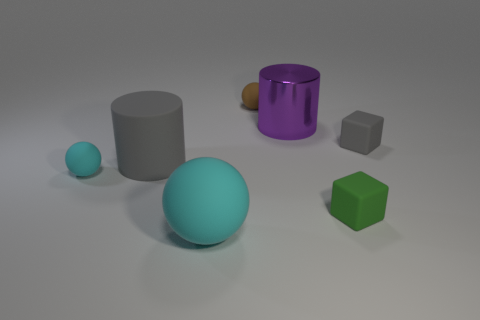Add 3 tiny brown balls. How many objects exist? 10 Subtract all cylinders. How many objects are left? 5 Subtract all purple objects. Subtract all small gray blocks. How many objects are left? 5 Add 7 metal things. How many metal things are left? 8 Add 3 small matte objects. How many small matte objects exist? 7 Subtract 1 brown balls. How many objects are left? 6 